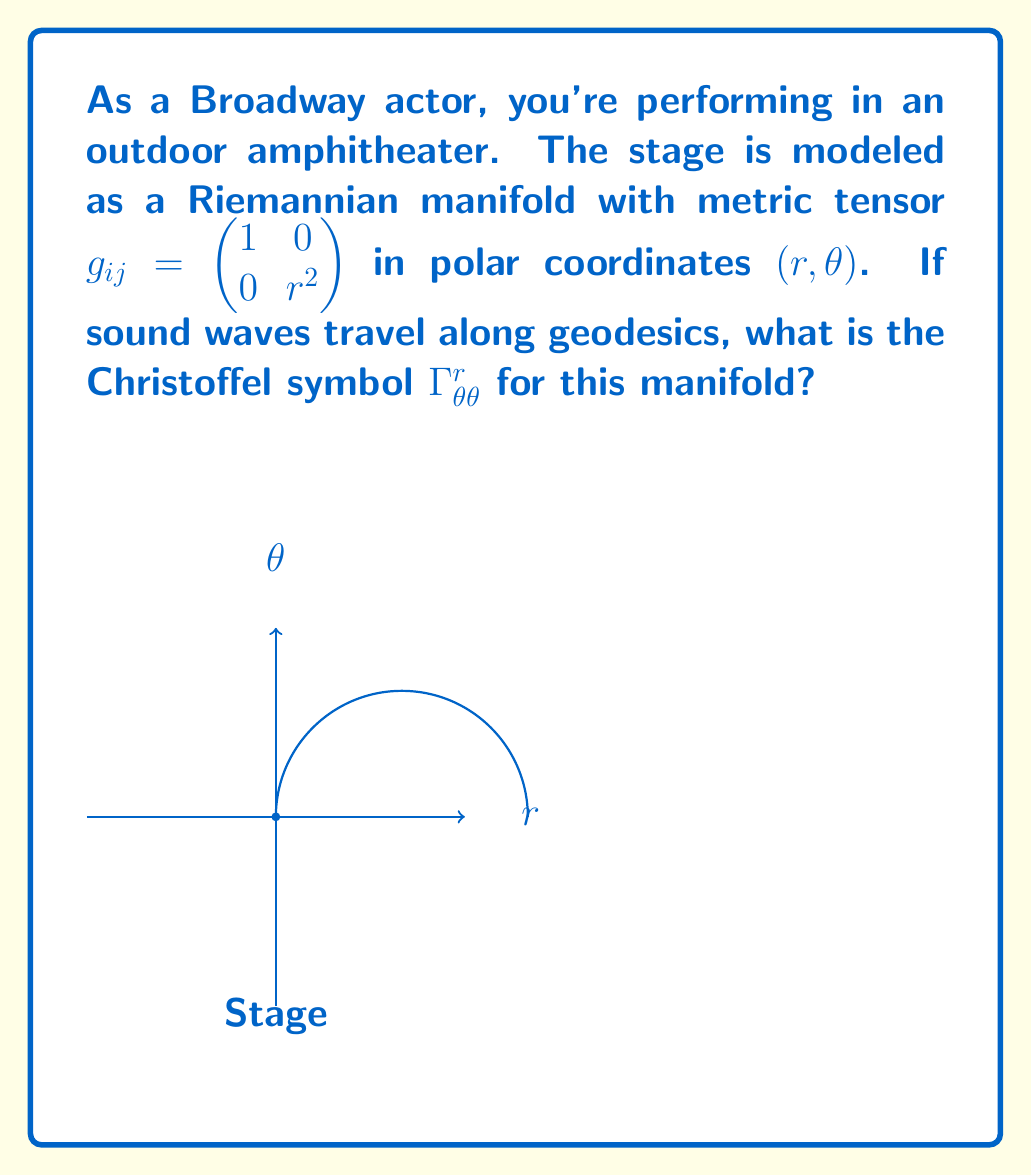Teach me how to tackle this problem. Let's approach this step-by-step:

1) The Christoffel symbols are given by the formula:

   $$\Gamma^k_{ij} = \frac{1}{2}g^{kl}\left(\frac{\partial g_{il}}{\partial x^j} + \frac{\partial g_{jl}}{\partial x^i} - \frac{\partial g_{ij}}{\partial x^l}\right)$$

2) We're looking for $\Gamma^r_{\theta\theta}$, so $k=r$, $i=j=\theta$.

3) First, we need to find $g^{kl}$. The metric tensor $g_{ij}$ is diagonal, so its inverse is:

   $$g^{ij} = \begin{pmatrix} 1 & 0 \\ 0 & \frac{1}{r^2} \end{pmatrix}$$

4) Now, let's calculate each term inside the parentheses:

   $\frac{\partial g_{\theta l}}{\partial \theta} = 0$ for both $l=r$ and $l=\theta$
   $\frac{\partial g_{\theta l}}{\partial \theta} = 0$ for both $l=r$ and $l=\theta$
   $\frac{\partial g_{\theta\theta}}{\partial r} = \frac{\partial (r^2)}{\partial r} = 2r$

5) Substituting into the formula:

   $$\Gamma^r_{\theta\theta} = \frac{1}{2}(g^{rr} \cdot 2r + g^{r\theta} \cdot 0 + g^{r\theta} \cdot 0 - g^{rr} \cdot 0)$$

6) Simplifying:

   $$\Gamma^r_{\theta\theta} = \frac{1}{2}(1 \cdot 2r) = r$$

Thus, we find that $\Gamma^r_{\theta\theta} = r$ for this Riemannian manifold.
Answer: $r$ 